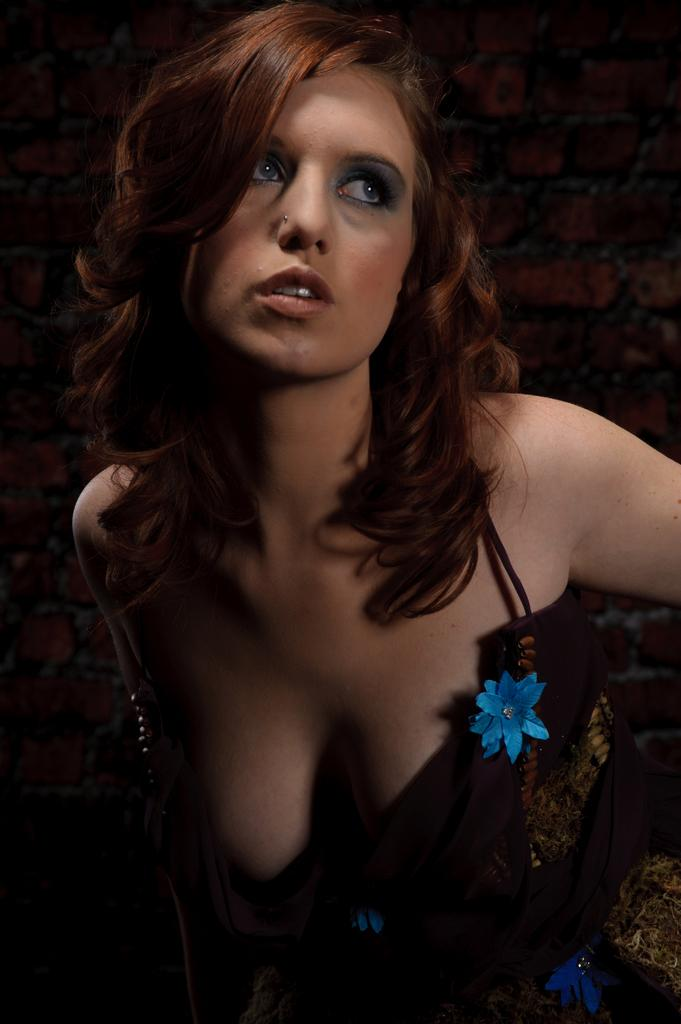Who is present in the image? There is a lady in the image. What can be seen in the background of the image? There is a brick wall in the background of the image. Is the lady wearing a crown in the image? There is no crown visible on the lady in the image. Can you see a trail leading to the brick wall in the image? There is no trail visible in the image; it only features a lady and a brick wall. 